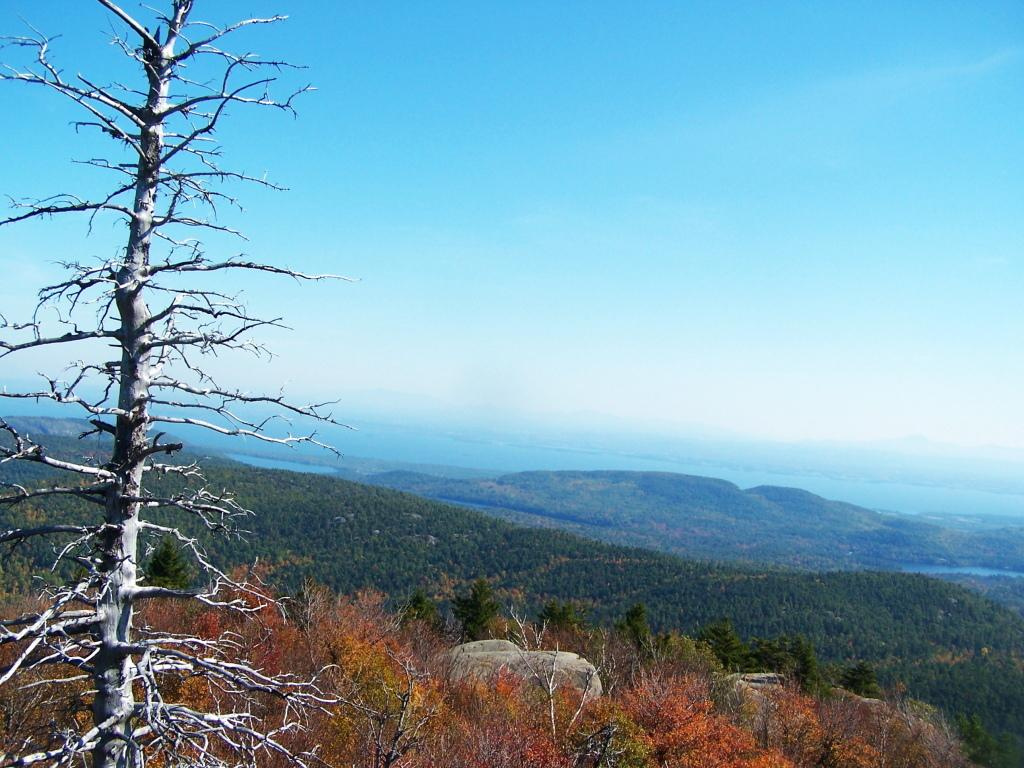What type of natural feature is on the left side of the image? There is a dried tree on the left side of the image. What can be seen in the center of the image? There are mountains and a lake in the center of the image. What is visible at the top of the image? The sky is visible at the top of the image. What type of silver object is present in the image? There is no silver object present in the image. What territory is being claimed by the mountains in the image? The mountains in the image are not claiming any territory; they are simply a natural feature. 